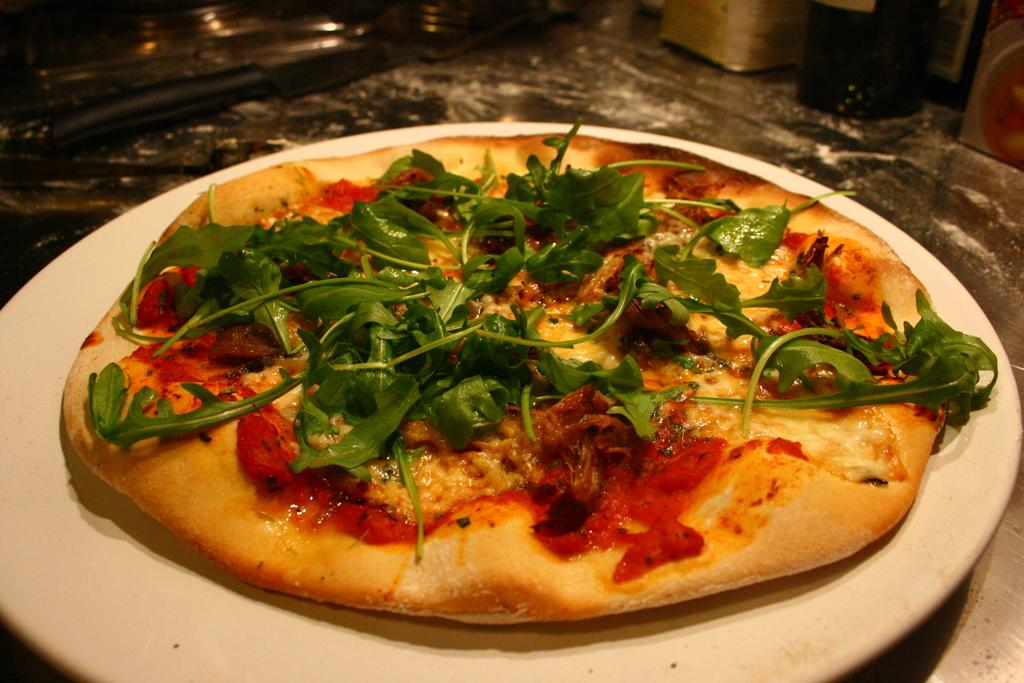What is the main subject in the foreground of the image? There is a pizza in the foreground of the image. What is unique about the pizza? The pizza has green leaves on it. How is the pizza presented in the image? The pizza is on a platter. What tool is visible at the top of the image? There is a knife visible at the top of the image. What other objects can be seen on the surface in the image? There are additional objects on the surface in the image. How many feet can be seen walking on the pizza in the image? There are no feet visible in the image, and no one is walking on the pizza. What type of cherries are placed on top of the pizza in the image? There are no cherries present on the pizza in the image. 